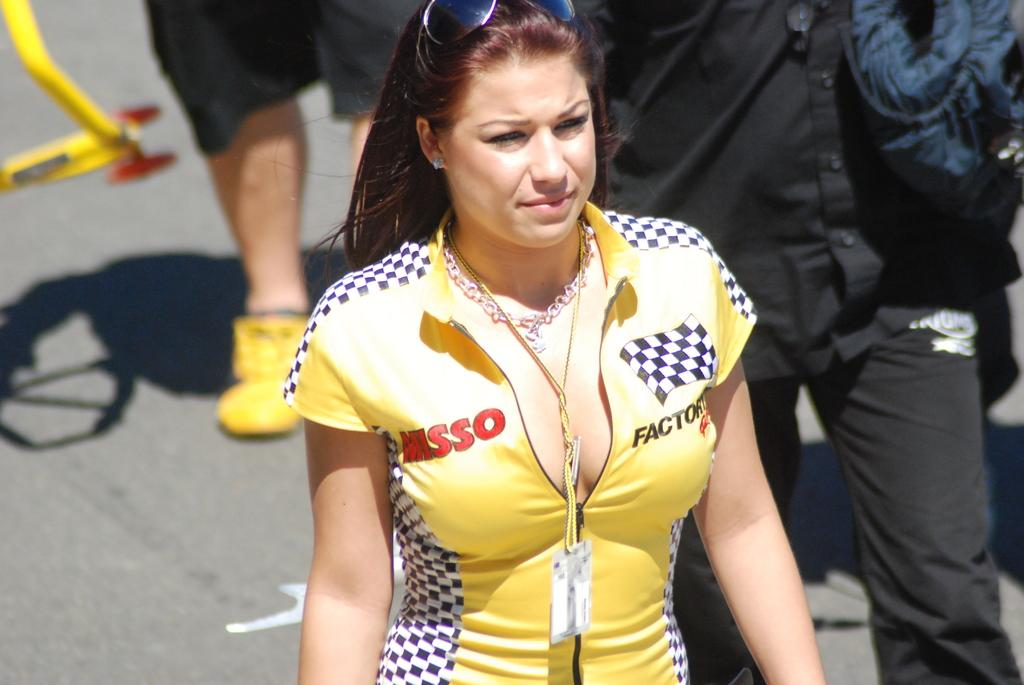<image>
Relay a brief, clear account of the picture shown. Girl wearing a yellow outfit which says MISSO on it. 